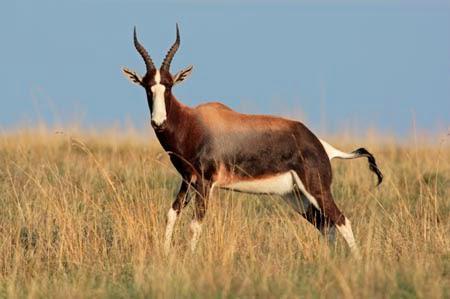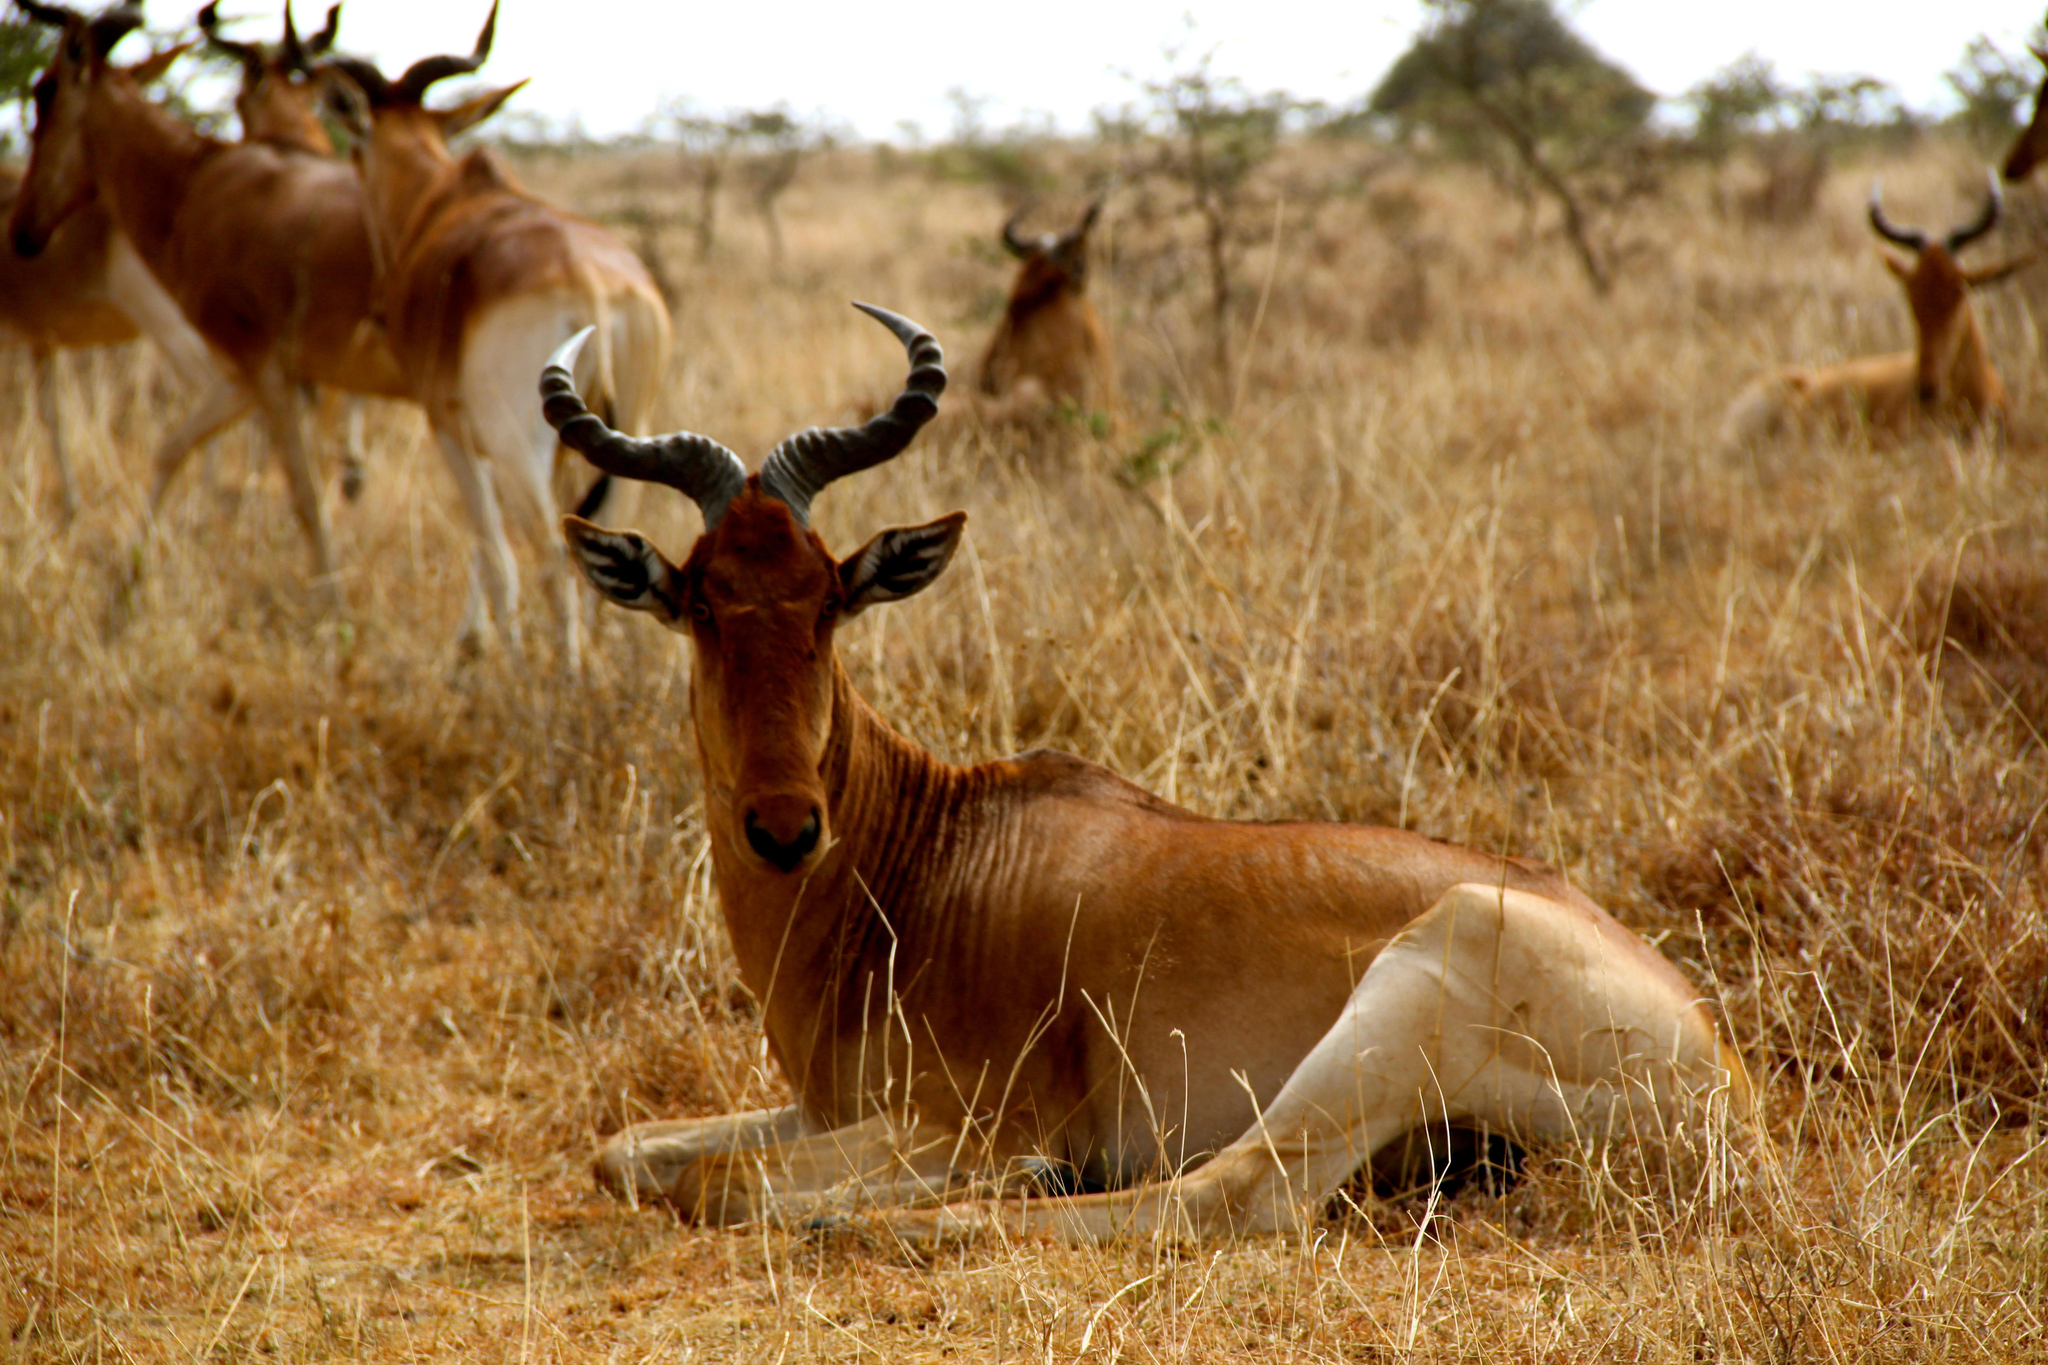The first image is the image on the left, the second image is the image on the right. For the images shown, is this caption "An image features exactly one horned animal, and it looks toward the camera." true? Answer yes or no. Yes. The first image is the image on the left, the second image is the image on the right. Evaluate the accuracy of this statement regarding the images: "One of the images shows exactly one antelope.". Is it true? Answer yes or no. Yes. 